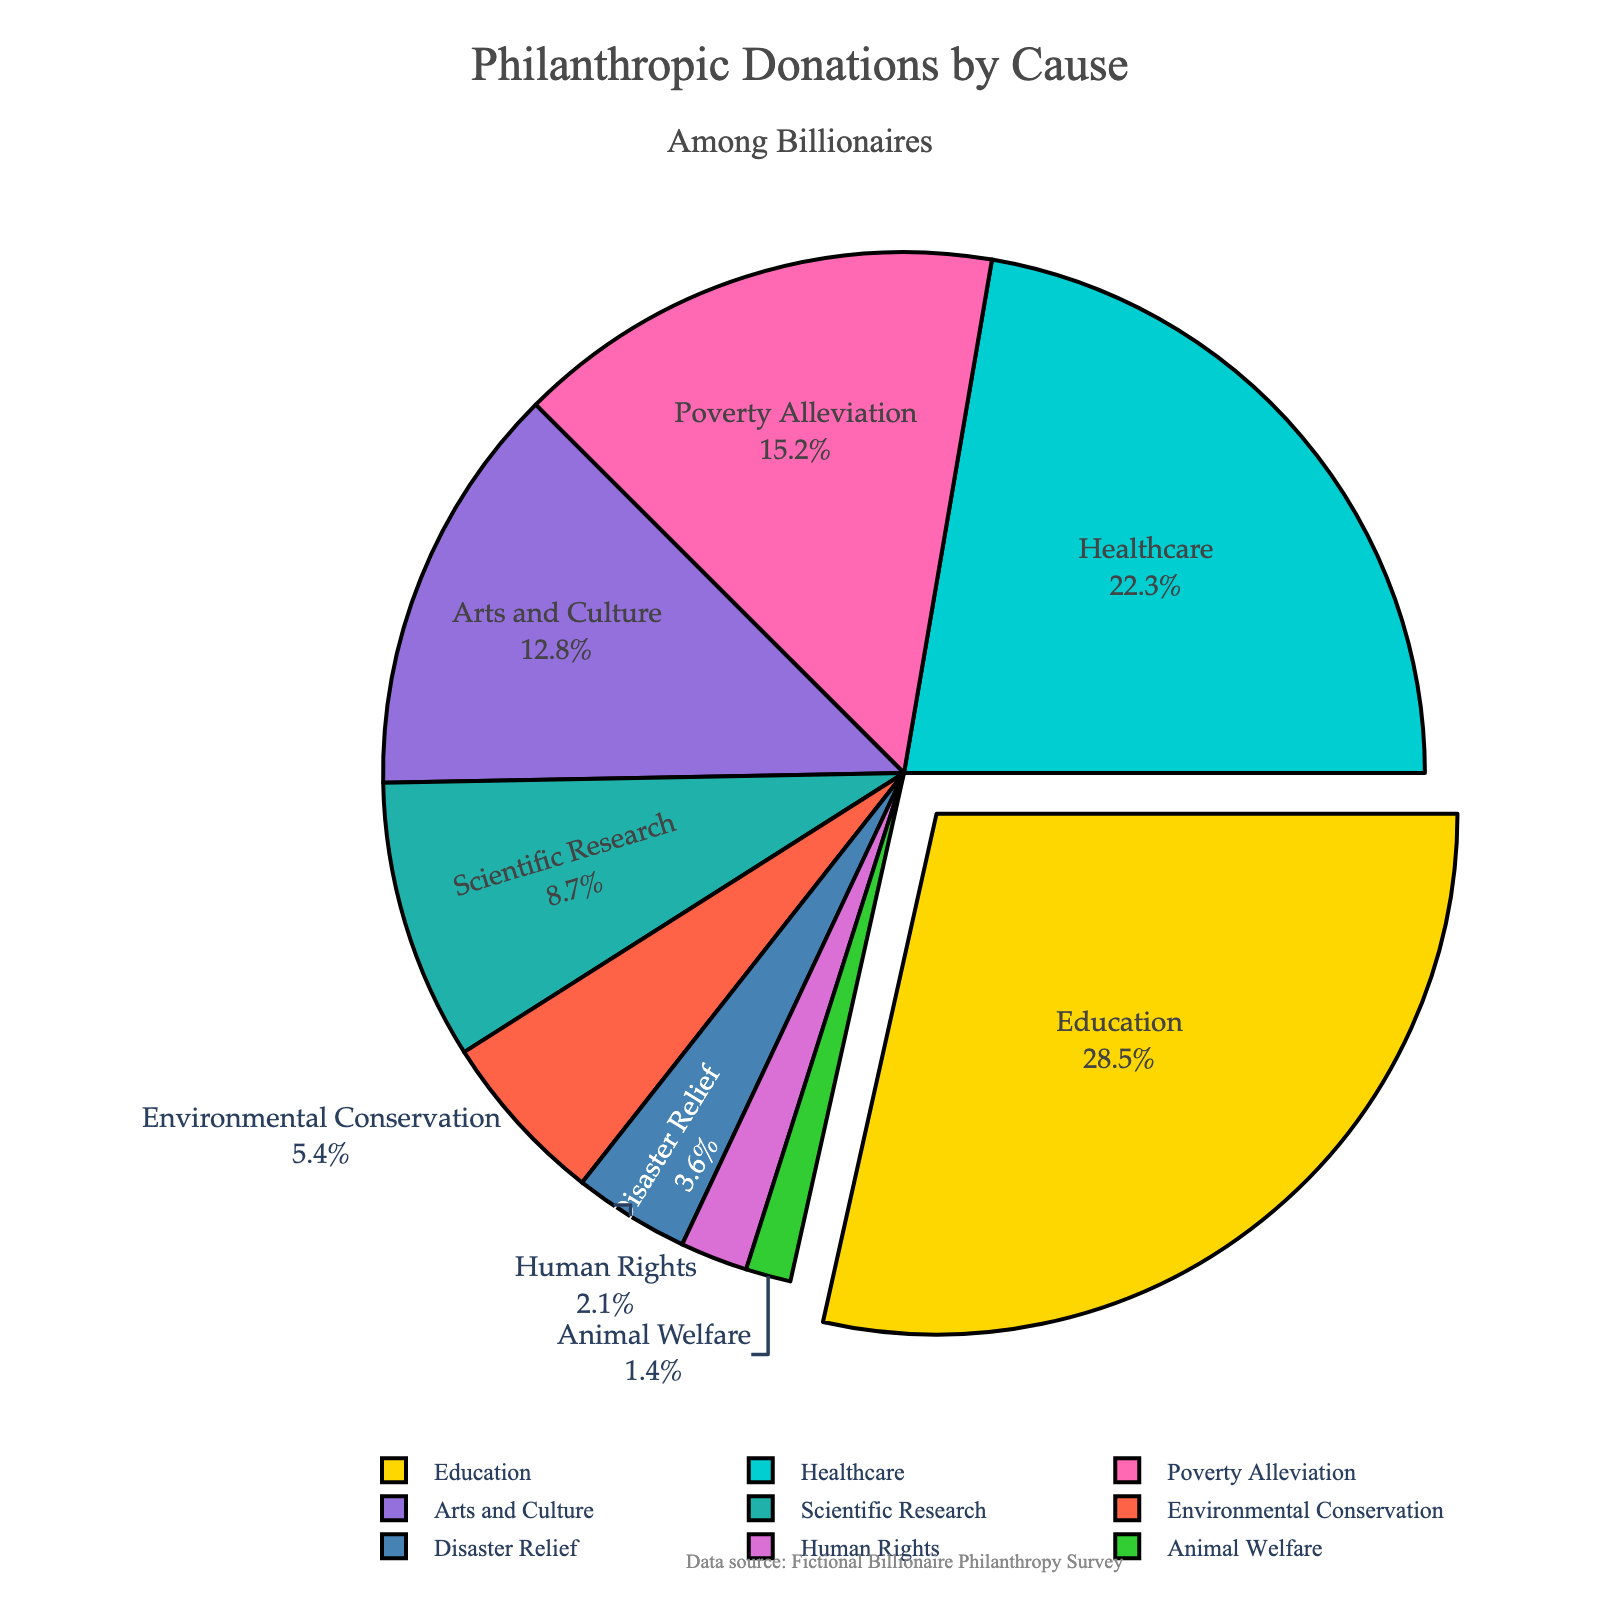What proportion of donations go towards Education and Healthcare combined? Add the percentages for Education and Healthcare: 28.5% + 22.3% = 50.8%
Answer: 50.8% Which cause receives the least amount of donations? Identify the cause with the smallest percentage, which is Animal Welfare at 1.4%
Answer: Animal Welfare Do Arts and Culture receive more or less funding than Scientific Research? Compare the percentages of Arts and Culture (12.8%) and Scientific Research (8.7%): 12.8% is greater than 8.7%
Answer: More What is the difference in donation percentage between Environmental Conservation and Disaster Relief? Subtract the percentage of Disaster Relief from Environmental Conservation: 5.4% - 3.6% = 1.8%
Answer: 1.8% By how much does Poverty Alleviation fall short of Education’s share of donations? Subtract the percentage of Poverty Alleviation from Education: 28.5% - 15.2% = 13.3%
Answer: 13.3% Which cause has the second-largest chunk of donations? Identify the cause with the second-highest percentage, which is Healthcare at 22.3%
Answer: Healthcare Is the combined percentage for Environmental Conservation and Human Rights greater than that for Poverty Alleviation? Add the percentages for Environmental Conservation (5.4%) and Human Rights (2.1%): 5.4% + 2.1% = 7.5%. Compare with Poverty Alleviation (15.2%). 7.5% is less than 15.2%
Answer: No If all areas combined total 100%, what fraction of donations is allocated to causes other than the three largest (Education, Healthcare, and Poverty Alleviation)? Sum the percentages of the three largest causes: 28.5% (Education) + 22.3% (Healthcare) + 15.2% (Poverty Alleviation) = 66%. Subtract from 100%: 100% - 66% = 34%
Answer: 34% Which segment is visually highlighted or "pulled out" in the pie chart? Look for the segment that appears pulled out or detached from the rest of the pie chart. This is the Education segment
Answer: Education How does the size of the Arts and Culture segment compare to the Environmental Conservation segment? Compare the percentages of Arts and Culture (12.8%) and Environmental Conservation (5.4%): 12.8% is significantly greater than 5.4%
Answer: Arts and Culture is larger 